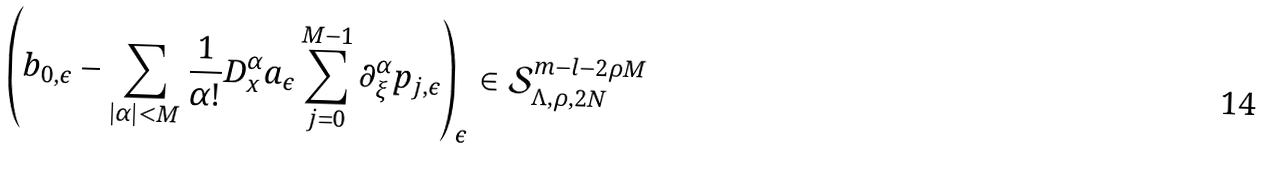Convert formula to latex. <formula><loc_0><loc_0><loc_500><loc_500>\left ( b _ { 0 , \epsilon } - \sum _ { | \alpha | < M } \frac { 1 } { \alpha ! } D ^ { \alpha } _ { x } a _ { \epsilon } \sum _ { j = 0 } ^ { M - 1 } \partial ^ { \alpha } _ { \xi } p _ { j , \epsilon } \right ) _ { \epsilon } \in \mathcal { S } ^ { m - l - 2 \rho M } _ { \Lambda , \rho , 2 N }</formula> 